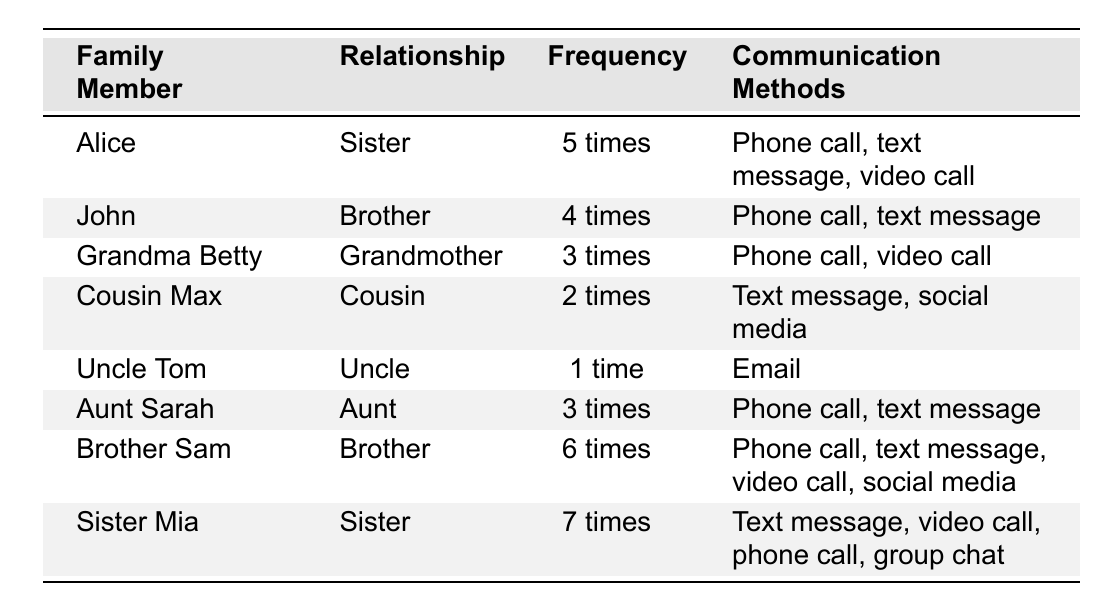What is the communication frequency with Sister Mia? Sister Mia communicates 7 times a week according to the table.
Answer: 7 times How many times does Brother Sam communicate per week? The table shows that Brother Sam communicates 6 times weekly.
Answer: 6 times Who communicates the least number of times? Uncle Tom communicates only 1 time per week, which is the lowest frequency listed.
Answer: Uncle Tom What is the average communication frequency among all family members? The frequencies are 5, 4, 3, 2, 1, 3, 6, and 7. Summing them: 5 + 4 + 3 + 2 + 1 + 3 + 6 + 7 = 31. There are 8 family members, so the average is 31/8 = 3.875.
Answer: 3.875 Which family member uses the most communication methods? Sister Mia uses 4 different methods (text message, video call, phone call, group chat), more than any other family member.
Answer: Sister Mia Is there any family member who only communicates via email? Yes, Uncle Tom communicates only by email, no other methods are listed for him.
Answer: Yes Compare the communication frequency of sisters Alice and Mia. Who communicates more? Alice communicates 5 times while Mia communicates 7 times. Since 7 is greater than 5, Mia communicates more.
Answer: Sister Mia What is the total communication frequency of all brothers combined? The frequencies for brothers are John (4 times), Brother Sam (6 times), and Alice (5 times). Summing these gives: 4 + 6 + 5 = 15.
Answer: 15 times Do any family members communicate using social media? Yes, both Cousin Max and Brother Sam utilize social media as a method of communication.
Answer: Yes How many family members communicate 3 times a week? Two family members (Grandma Betty and Aunt Sarah) communicate 3 times per week.
Answer: 2 members 